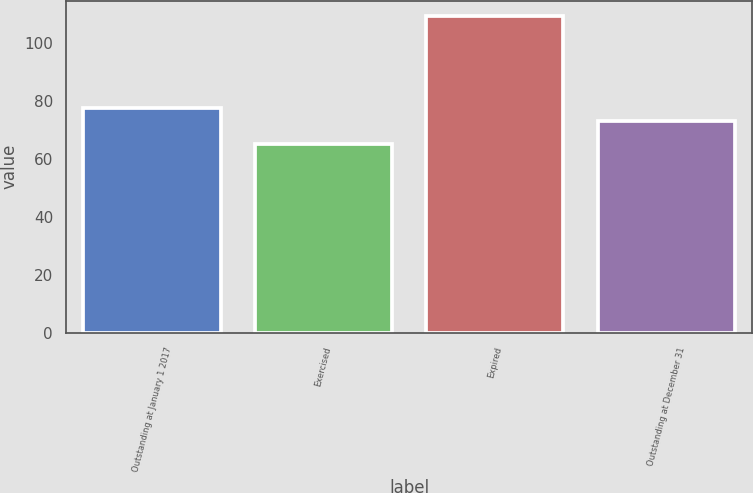<chart> <loc_0><loc_0><loc_500><loc_500><bar_chart><fcel>Outstanding at January 1 2017<fcel>Exercised<fcel>Expired<fcel>Outstanding at December 31<nl><fcel>77.34<fcel>64.92<fcel>109.05<fcel>72.93<nl></chart> 